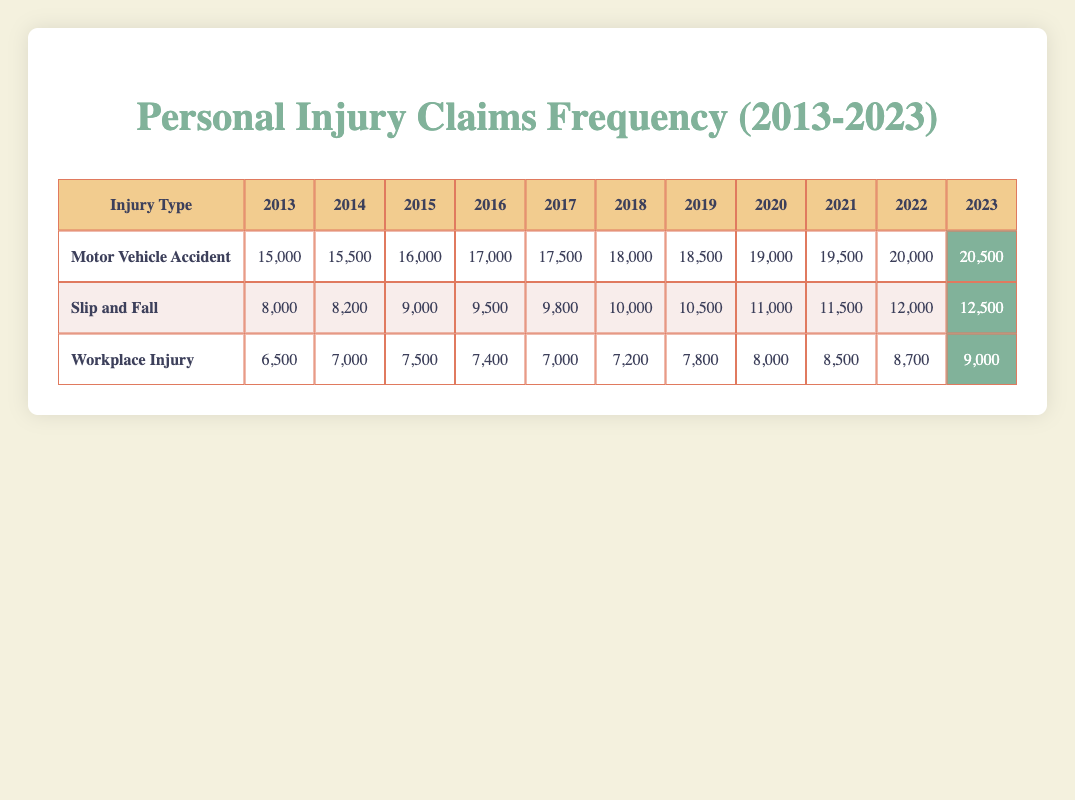What was the frequency of claims for Motor Vehicle Accidents in 2020? The table shows that in 2020, the frequency of claims for Motor Vehicle Accidents is recorded as 19,000.
Answer: 19,000 Which injury type had the highest number of claims in 2023? In 2023, the table indicates that Motor Vehicle Accident claims had the highest frequency at 20,500, compared to Slip and Fall at 12,500 and Workplace Injury at 9,000.
Answer: Motor Vehicle Accident What is the total number of workplace injury claims from 2013 to 2023? Summing the claims: 6,500 + 7,000 + 7,500 + 7,400 + 7,000 + 7,200 + 7,800 + 8,000 + 8,500 + 8,700 + 9,000 gives a total of 78,600.
Answer: 78,600 Is the frequency of Slip and Fall claims increasing every year? Examining the table, Slip and Fall claims increased each year from 2013 to 2023, starting from 8,000 in 2013 to 12,500 in 2023, indicating a consistent increase.
Answer: Yes What is the average frequency of claims for Workplace Injuries over the period 2013-2023? The total frequency for Workplace Injuries (6,500 + 7,000 + 7,500 + 7,400 + 7,000 + 7,200 + 7,800 + 8,000 + 8,500 + 8,700 + 9,000 = 78,600) is divided by the number of years (11) gives an average of 7,136.36.
Answer: 7,136 In which year did the claims for Motor Vehicle Accidents see the largest increase from the previous year? The largest yearly increase was from 2021 to 2022, going from 19,500 to 20,000, a difference of 500 claims. This is the maximum increase observed in the entire data set, making it the largest increment.
Answer: 2021 to 2022 What percentage increase in claims did Slip and Fall injuries see from 2013 to 2023? The claims increased from 8,000 in 2013 to 12,500 in 2023. The percentage increase is calculated as ((12,500 - 8,000) / 8,000) * 100, resulting in a 56.25% increase.
Answer: 56.25% Was there ever a year when claims for Motor Vehicle Accidents dropped compared to the previous year? Reviewing the table confirms that claims for Motor Vehicle Accidents consistently increased each year from 2013 to 2023, indicating no drops.
Answer: No Which injury type has the highest overall frequency of claims during this period? Looking at the sums of claims over 11 years for each type: Motor Vehicle Accidents total 200,500, Slip and Falls total 107,500, and Workplace Injuries total 78,600. Motor Vehicle Accidents have the highest frequency overall.
Answer: Motor Vehicle Accidents How many more claims were filed for Slip and Fall incidents than Workplace Injuries in 2022? In 2022, Slip and Fall claims total 12,000 and Workplace Injury claims total 8,700. The difference is 12,000 - 8,700 = 3,300 claims.
Answer: 3,300 